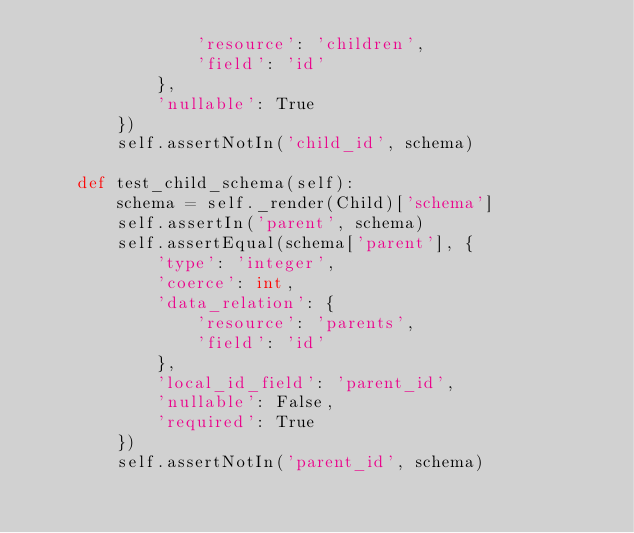Convert code to text. <code><loc_0><loc_0><loc_500><loc_500><_Python_>                'resource': 'children',
                'field': 'id'
            },
            'nullable': True
        })
        self.assertNotIn('child_id', schema)

    def test_child_schema(self):
        schema = self._render(Child)['schema']
        self.assertIn('parent', schema)
        self.assertEqual(schema['parent'], {
            'type': 'integer',
            'coerce': int,
            'data_relation': {
                'resource': 'parents',
                'field': 'id'
            },
            'local_id_field': 'parent_id',
            'nullable': False,
            'required': True
        })
        self.assertNotIn('parent_id', schema)
</code> 